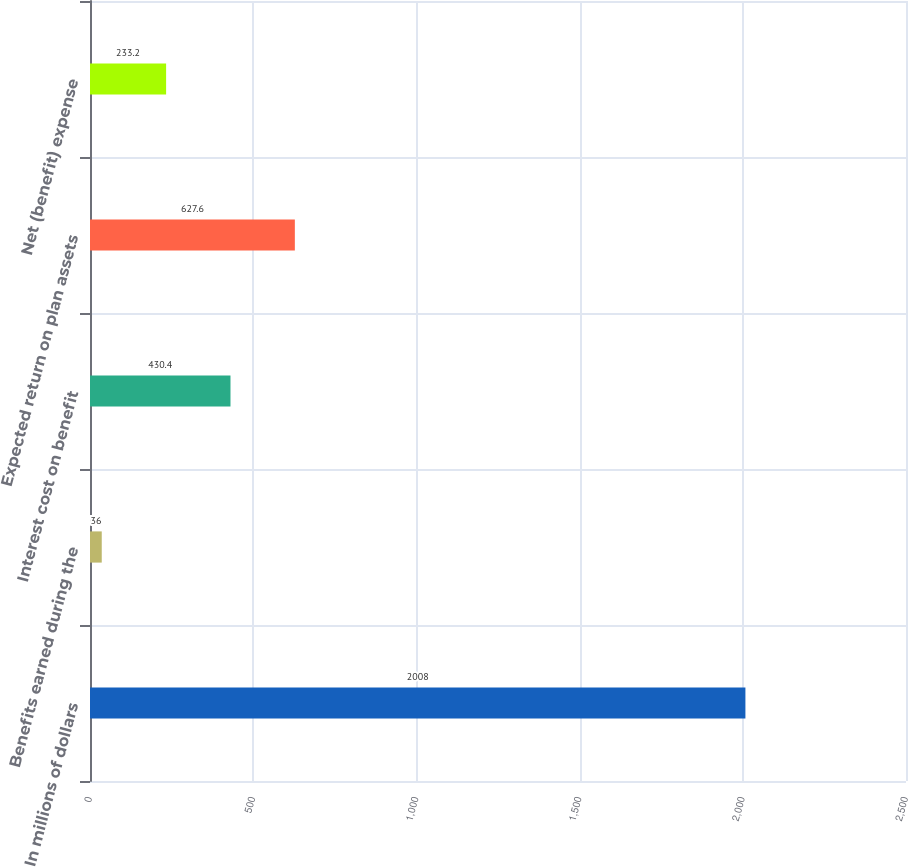Convert chart. <chart><loc_0><loc_0><loc_500><loc_500><bar_chart><fcel>In millions of dollars<fcel>Benefits earned during the<fcel>Interest cost on benefit<fcel>Expected return on plan assets<fcel>Net (benefit) expense<nl><fcel>2008<fcel>36<fcel>430.4<fcel>627.6<fcel>233.2<nl></chart> 